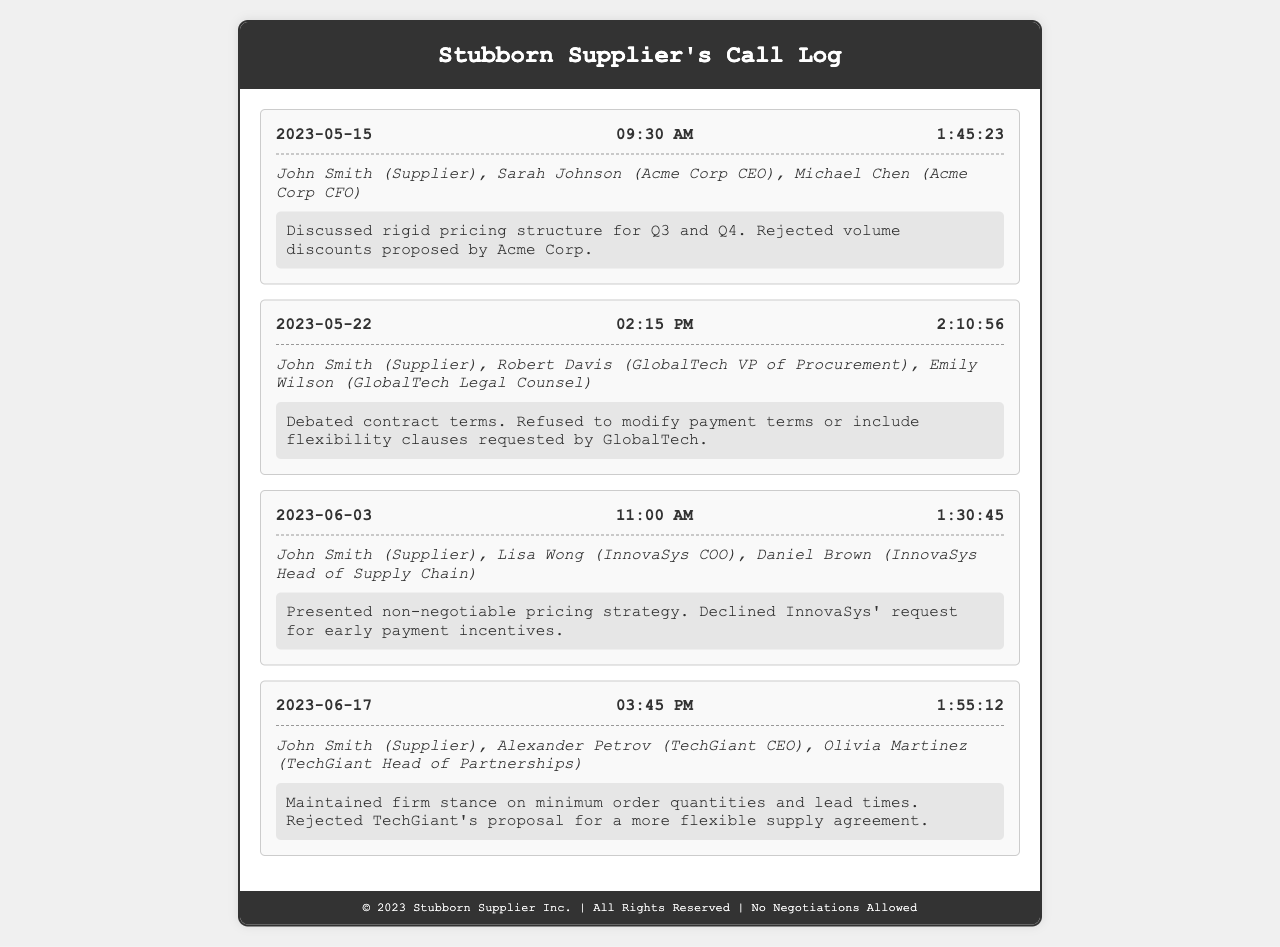What is the date of the first call? The date of the first call is mentioned in the log as 2023-05-15.
Answer: 2023-05-15 Who were the participants in the second call? The participants in the second call include John Smith, Robert Davis, and Emily Wilson.
Answer: John Smith, Robert Davis, Emily Wilson What was discussed in the call on 2023-06-03? The summary of the call on that date indicates a presentation of a non-negotiable pricing strategy and a decline of early payment incentives requested by InnovaSys.
Answer: Non-negotiable pricing strategy What is the duration of the call held on 2023-05-22? The duration is provided alongside the call details for 2023-05-22, which is 2:10:56.
Answer: 2:10:56 How many calls are recorded in the document? The total number of calls is calculated by counting the entries in the call log section which lists four different calls.
Answer: 4 Which company’s proposal was rejected in the call on 2023-06-17? The summary of the call indicates that the proposal from TechGiant was rejected.
Answer: TechGiant What was the main reason for rejecting volume discounts? The summary of the first call states that a rigid pricing structure for Q3 and Q4 was discussed, which underlies the rejection of volume discounts.
Answer: Rigid pricing structure What was the stance on payment terms in the second call? It was noted in the summary that there was a refusal to modify payment terms as discussed during the call.
Answer: Refused to modify Was there any flexibility offered in the pricing strategy during the calls? The summaries across all calls indicate a consistent refusal to incorporate flexibility strategies into the pricing.
Answer: No flexibility offered 